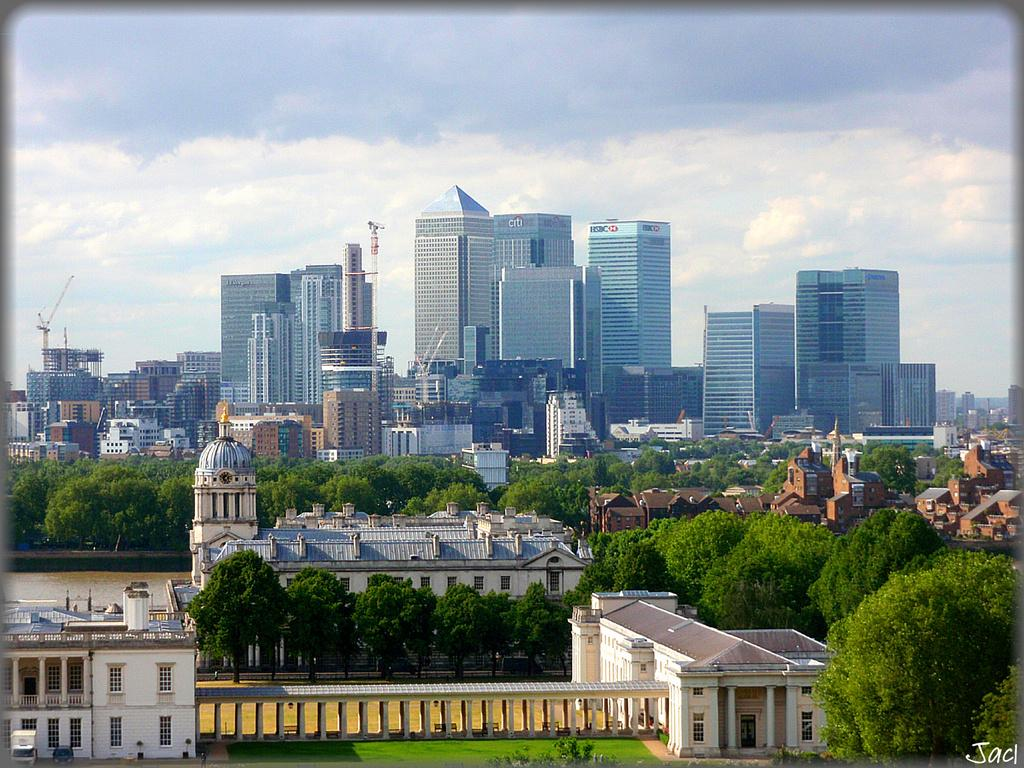What type of structures can be seen in the image? There is a group of buildings, a tower, and houses in the image. What is the purpose of the crane in the image? The presence of a crane suggests that construction or renovation work might be taking place. What type of vegetation is visible in the image? There is a group of trees and grass visible in the image. What architectural feature can be seen in the image? There is a roof with pillars in the image. What natural element is visible in the image? Water is visible in the image. What is the weather like in the image? The sky is cloudy in the image. What type of noise can be heard coming from the eggs in the image? There are no eggs present in the image, so it is not possible to determine what noise might be coming from them. 